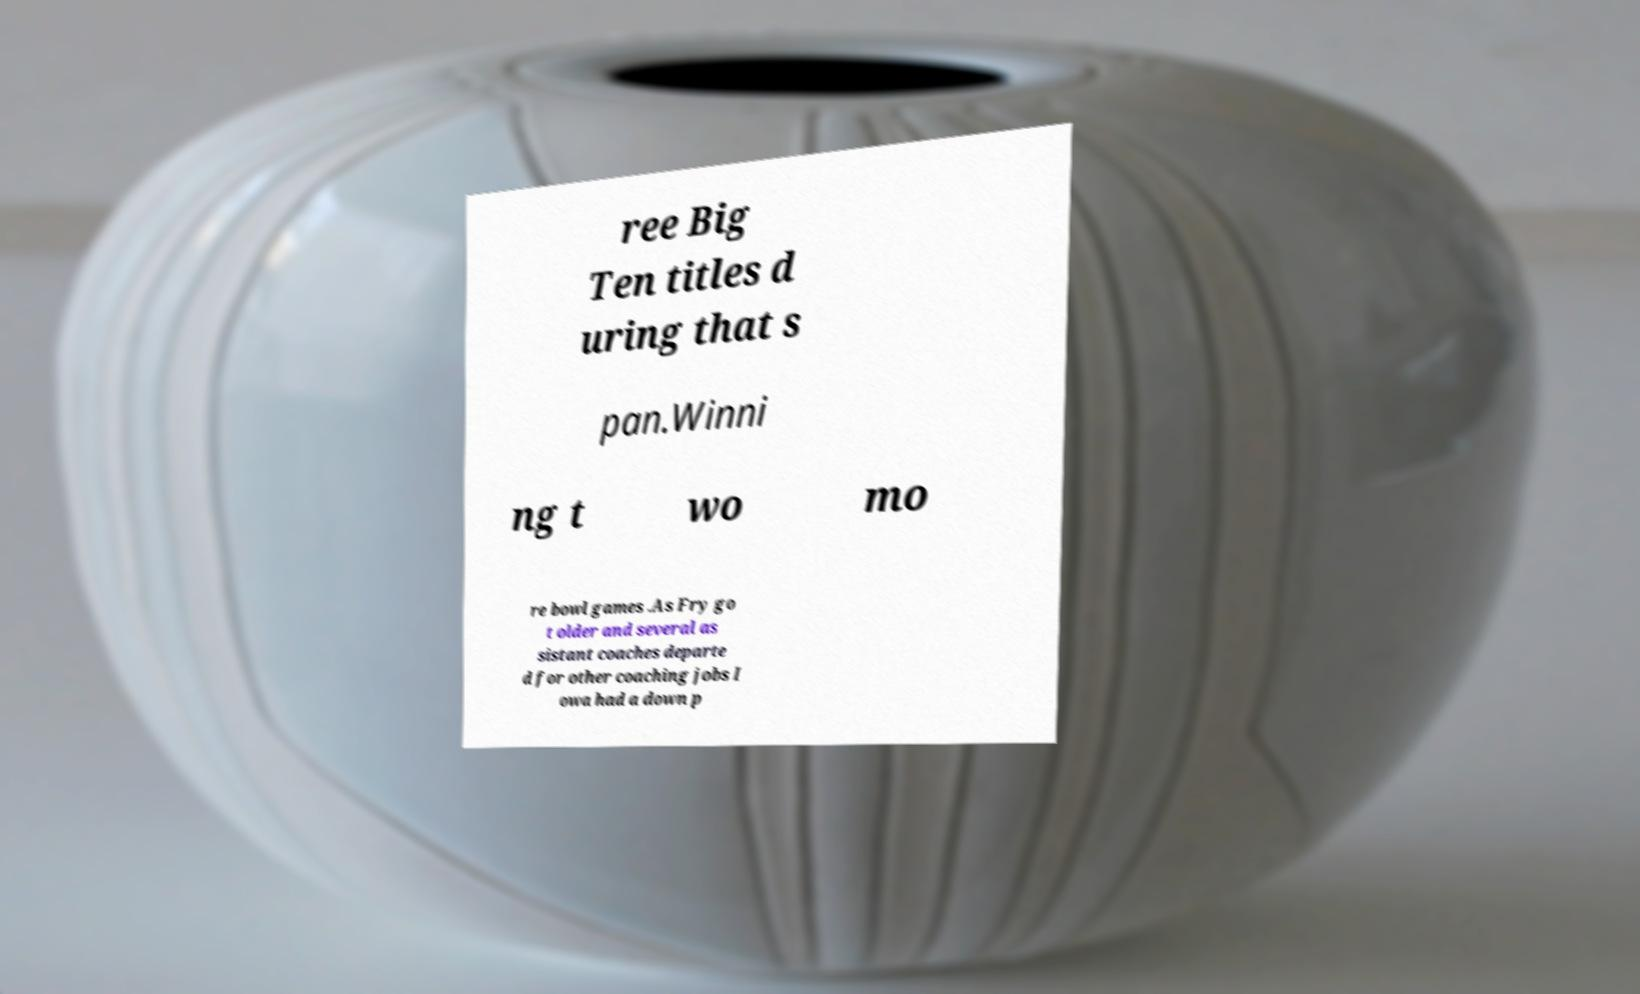What messages or text are displayed in this image? I need them in a readable, typed format. ree Big Ten titles d uring that s pan.Winni ng t wo mo re bowl games .As Fry go t older and several as sistant coaches departe d for other coaching jobs I owa had a down p 